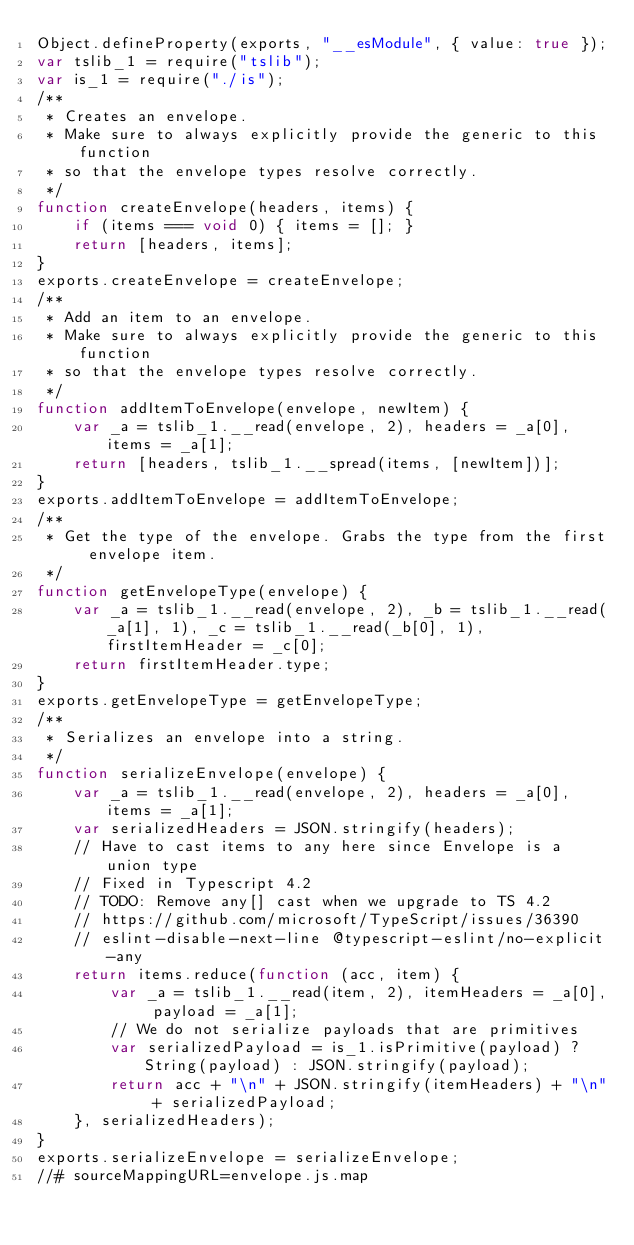Convert code to text. <code><loc_0><loc_0><loc_500><loc_500><_JavaScript_>Object.defineProperty(exports, "__esModule", { value: true });
var tslib_1 = require("tslib");
var is_1 = require("./is");
/**
 * Creates an envelope.
 * Make sure to always explicitly provide the generic to this function
 * so that the envelope types resolve correctly.
 */
function createEnvelope(headers, items) {
    if (items === void 0) { items = []; }
    return [headers, items];
}
exports.createEnvelope = createEnvelope;
/**
 * Add an item to an envelope.
 * Make sure to always explicitly provide the generic to this function
 * so that the envelope types resolve correctly.
 */
function addItemToEnvelope(envelope, newItem) {
    var _a = tslib_1.__read(envelope, 2), headers = _a[0], items = _a[1];
    return [headers, tslib_1.__spread(items, [newItem])];
}
exports.addItemToEnvelope = addItemToEnvelope;
/**
 * Get the type of the envelope. Grabs the type from the first envelope item.
 */
function getEnvelopeType(envelope) {
    var _a = tslib_1.__read(envelope, 2), _b = tslib_1.__read(_a[1], 1), _c = tslib_1.__read(_b[0], 1), firstItemHeader = _c[0];
    return firstItemHeader.type;
}
exports.getEnvelopeType = getEnvelopeType;
/**
 * Serializes an envelope into a string.
 */
function serializeEnvelope(envelope) {
    var _a = tslib_1.__read(envelope, 2), headers = _a[0], items = _a[1];
    var serializedHeaders = JSON.stringify(headers);
    // Have to cast items to any here since Envelope is a union type
    // Fixed in Typescript 4.2
    // TODO: Remove any[] cast when we upgrade to TS 4.2
    // https://github.com/microsoft/TypeScript/issues/36390
    // eslint-disable-next-line @typescript-eslint/no-explicit-any
    return items.reduce(function (acc, item) {
        var _a = tslib_1.__read(item, 2), itemHeaders = _a[0], payload = _a[1];
        // We do not serialize payloads that are primitives
        var serializedPayload = is_1.isPrimitive(payload) ? String(payload) : JSON.stringify(payload);
        return acc + "\n" + JSON.stringify(itemHeaders) + "\n" + serializedPayload;
    }, serializedHeaders);
}
exports.serializeEnvelope = serializeEnvelope;
//# sourceMappingURL=envelope.js.map</code> 